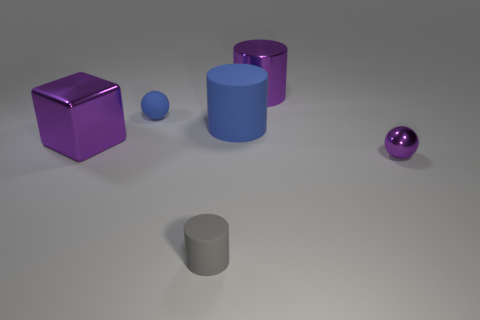What shape is the large purple thing that is the same material as the block?
Keep it short and to the point. Cylinder. Is there anything else that has the same shape as the tiny blue rubber object?
Your answer should be very brief. Yes. Does the object that is in front of the tiny purple metal ball have the same material as the purple cylinder?
Make the answer very short. No. What is the sphere that is behind the tiny purple thing made of?
Your answer should be very brief. Rubber. There is a rubber cylinder that is behind the purple block in front of the big purple cylinder; what size is it?
Provide a short and direct response. Large. How many purple metallic spheres have the same size as the shiny cylinder?
Offer a very short reply. 0. Is the color of the ball in front of the tiny blue sphere the same as the large metallic thing left of the gray object?
Provide a short and direct response. Yes. Are there any purple shiny cylinders in front of the blue matte sphere?
Your response must be concise. No. There is a large object that is both in front of the tiny rubber ball and on the right side of the small gray rubber cylinder; what color is it?
Ensure brevity in your answer.  Blue. Is there a rubber ball that has the same color as the big matte thing?
Keep it short and to the point. Yes. 